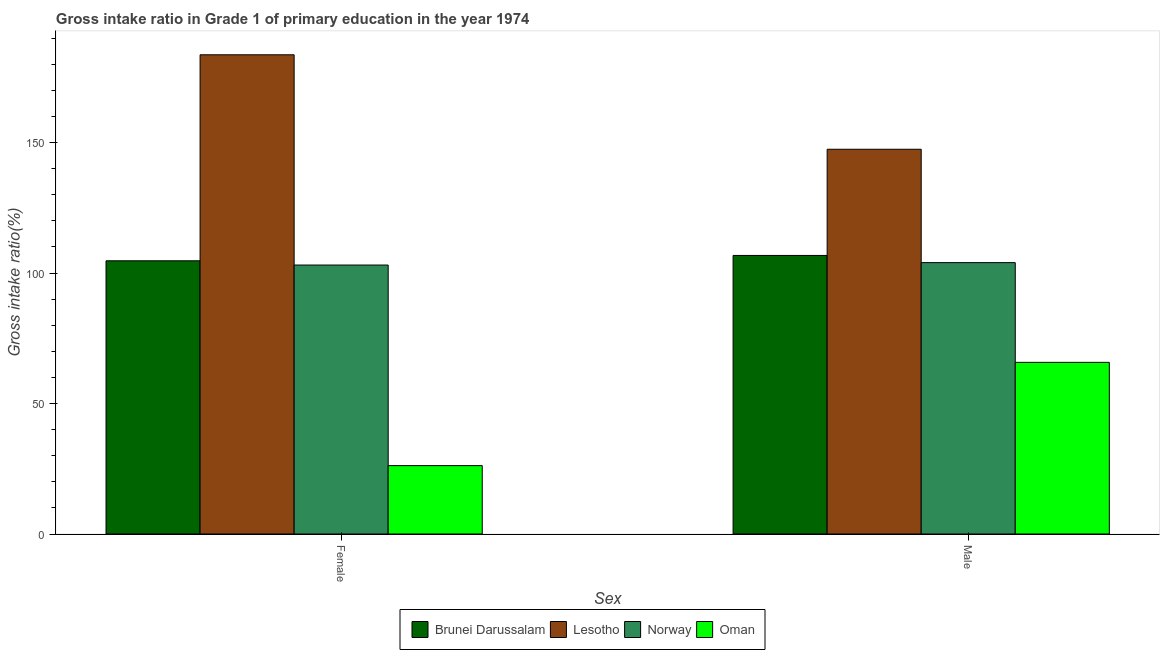How many different coloured bars are there?
Your response must be concise. 4. How many groups of bars are there?
Provide a short and direct response. 2. What is the label of the 1st group of bars from the left?
Ensure brevity in your answer.  Female. What is the gross intake ratio(male) in Lesotho?
Your response must be concise. 147.44. Across all countries, what is the maximum gross intake ratio(female)?
Offer a terse response. 183.65. Across all countries, what is the minimum gross intake ratio(male)?
Your answer should be compact. 65.78. In which country was the gross intake ratio(female) maximum?
Offer a very short reply. Lesotho. In which country was the gross intake ratio(female) minimum?
Your answer should be compact. Oman. What is the total gross intake ratio(female) in the graph?
Offer a terse response. 417.62. What is the difference between the gross intake ratio(male) in Oman and that in Lesotho?
Offer a terse response. -81.66. What is the difference between the gross intake ratio(male) in Norway and the gross intake ratio(female) in Oman?
Your answer should be very brief. 77.79. What is the average gross intake ratio(female) per country?
Your response must be concise. 104.4. What is the difference between the gross intake ratio(male) and gross intake ratio(female) in Lesotho?
Provide a short and direct response. -36.2. In how many countries, is the gross intake ratio(female) greater than 50 %?
Your response must be concise. 3. What is the ratio of the gross intake ratio(female) in Brunei Darussalam to that in Lesotho?
Provide a succinct answer. 0.57. Is the gross intake ratio(female) in Norway less than that in Oman?
Offer a terse response. No. What does the 2nd bar from the left in Male represents?
Offer a terse response. Lesotho. What does the 1st bar from the right in Male represents?
Offer a very short reply. Oman. What is the difference between two consecutive major ticks on the Y-axis?
Provide a succinct answer. 50. Does the graph contain grids?
Provide a short and direct response. No. How many legend labels are there?
Keep it short and to the point. 4. How are the legend labels stacked?
Provide a short and direct response. Horizontal. What is the title of the graph?
Make the answer very short. Gross intake ratio in Grade 1 of primary education in the year 1974. What is the label or title of the X-axis?
Offer a very short reply. Sex. What is the label or title of the Y-axis?
Your response must be concise. Gross intake ratio(%). What is the Gross intake ratio(%) in Brunei Darussalam in Female?
Give a very brief answer. 104.7. What is the Gross intake ratio(%) in Lesotho in Female?
Make the answer very short. 183.65. What is the Gross intake ratio(%) in Norway in Female?
Make the answer very short. 103.07. What is the Gross intake ratio(%) of Oman in Female?
Your answer should be compact. 26.2. What is the Gross intake ratio(%) in Brunei Darussalam in Male?
Your answer should be compact. 106.75. What is the Gross intake ratio(%) of Lesotho in Male?
Your answer should be compact. 147.44. What is the Gross intake ratio(%) of Norway in Male?
Offer a terse response. 104. What is the Gross intake ratio(%) of Oman in Male?
Give a very brief answer. 65.78. Across all Sex, what is the maximum Gross intake ratio(%) in Brunei Darussalam?
Make the answer very short. 106.75. Across all Sex, what is the maximum Gross intake ratio(%) in Lesotho?
Offer a terse response. 183.65. Across all Sex, what is the maximum Gross intake ratio(%) of Norway?
Provide a short and direct response. 104. Across all Sex, what is the maximum Gross intake ratio(%) of Oman?
Ensure brevity in your answer.  65.78. Across all Sex, what is the minimum Gross intake ratio(%) in Brunei Darussalam?
Your response must be concise. 104.7. Across all Sex, what is the minimum Gross intake ratio(%) of Lesotho?
Provide a succinct answer. 147.44. Across all Sex, what is the minimum Gross intake ratio(%) in Norway?
Offer a very short reply. 103.07. Across all Sex, what is the minimum Gross intake ratio(%) of Oman?
Provide a succinct answer. 26.2. What is the total Gross intake ratio(%) of Brunei Darussalam in the graph?
Ensure brevity in your answer.  211.45. What is the total Gross intake ratio(%) of Lesotho in the graph?
Your response must be concise. 331.09. What is the total Gross intake ratio(%) in Norway in the graph?
Your answer should be compact. 207.07. What is the total Gross intake ratio(%) in Oman in the graph?
Your answer should be very brief. 91.99. What is the difference between the Gross intake ratio(%) in Brunei Darussalam in Female and that in Male?
Give a very brief answer. -2.05. What is the difference between the Gross intake ratio(%) in Lesotho in Female and that in Male?
Your answer should be very brief. 36.2. What is the difference between the Gross intake ratio(%) in Norway in Female and that in Male?
Provide a succinct answer. -0.92. What is the difference between the Gross intake ratio(%) in Oman in Female and that in Male?
Offer a terse response. -39.58. What is the difference between the Gross intake ratio(%) of Brunei Darussalam in Female and the Gross intake ratio(%) of Lesotho in Male?
Your response must be concise. -42.75. What is the difference between the Gross intake ratio(%) in Brunei Darussalam in Female and the Gross intake ratio(%) in Norway in Male?
Your response must be concise. 0.7. What is the difference between the Gross intake ratio(%) of Brunei Darussalam in Female and the Gross intake ratio(%) of Oman in Male?
Ensure brevity in your answer.  38.92. What is the difference between the Gross intake ratio(%) in Lesotho in Female and the Gross intake ratio(%) in Norway in Male?
Your response must be concise. 79.65. What is the difference between the Gross intake ratio(%) in Lesotho in Female and the Gross intake ratio(%) in Oman in Male?
Your response must be concise. 117.86. What is the difference between the Gross intake ratio(%) in Norway in Female and the Gross intake ratio(%) in Oman in Male?
Ensure brevity in your answer.  37.29. What is the average Gross intake ratio(%) in Brunei Darussalam per Sex?
Give a very brief answer. 105.72. What is the average Gross intake ratio(%) of Lesotho per Sex?
Your response must be concise. 165.55. What is the average Gross intake ratio(%) of Norway per Sex?
Your response must be concise. 103.53. What is the average Gross intake ratio(%) of Oman per Sex?
Ensure brevity in your answer.  45.99. What is the difference between the Gross intake ratio(%) in Brunei Darussalam and Gross intake ratio(%) in Lesotho in Female?
Offer a terse response. -78.95. What is the difference between the Gross intake ratio(%) in Brunei Darussalam and Gross intake ratio(%) in Norway in Female?
Offer a very short reply. 1.63. What is the difference between the Gross intake ratio(%) of Brunei Darussalam and Gross intake ratio(%) of Oman in Female?
Make the answer very short. 78.49. What is the difference between the Gross intake ratio(%) in Lesotho and Gross intake ratio(%) in Norway in Female?
Your answer should be very brief. 80.57. What is the difference between the Gross intake ratio(%) of Lesotho and Gross intake ratio(%) of Oman in Female?
Make the answer very short. 157.44. What is the difference between the Gross intake ratio(%) of Norway and Gross intake ratio(%) of Oman in Female?
Keep it short and to the point. 76.87. What is the difference between the Gross intake ratio(%) of Brunei Darussalam and Gross intake ratio(%) of Lesotho in Male?
Your answer should be compact. -40.69. What is the difference between the Gross intake ratio(%) in Brunei Darussalam and Gross intake ratio(%) in Norway in Male?
Give a very brief answer. 2.76. What is the difference between the Gross intake ratio(%) of Brunei Darussalam and Gross intake ratio(%) of Oman in Male?
Offer a very short reply. 40.97. What is the difference between the Gross intake ratio(%) in Lesotho and Gross intake ratio(%) in Norway in Male?
Ensure brevity in your answer.  43.45. What is the difference between the Gross intake ratio(%) in Lesotho and Gross intake ratio(%) in Oman in Male?
Provide a short and direct response. 81.66. What is the difference between the Gross intake ratio(%) of Norway and Gross intake ratio(%) of Oman in Male?
Provide a succinct answer. 38.21. What is the ratio of the Gross intake ratio(%) in Brunei Darussalam in Female to that in Male?
Offer a terse response. 0.98. What is the ratio of the Gross intake ratio(%) in Lesotho in Female to that in Male?
Keep it short and to the point. 1.25. What is the ratio of the Gross intake ratio(%) in Oman in Female to that in Male?
Your answer should be very brief. 0.4. What is the difference between the highest and the second highest Gross intake ratio(%) in Brunei Darussalam?
Keep it short and to the point. 2.05. What is the difference between the highest and the second highest Gross intake ratio(%) of Lesotho?
Your answer should be very brief. 36.2. What is the difference between the highest and the second highest Gross intake ratio(%) in Norway?
Offer a very short reply. 0.92. What is the difference between the highest and the second highest Gross intake ratio(%) of Oman?
Offer a very short reply. 39.58. What is the difference between the highest and the lowest Gross intake ratio(%) of Brunei Darussalam?
Ensure brevity in your answer.  2.05. What is the difference between the highest and the lowest Gross intake ratio(%) of Lesotho?
Offer a very short reply. 36.2. What is the difference between the highest and the lowest Gross intake ratio(%) of Norway?
Offer a terse response. 0.92. What is the difference between the highest and the lowest Gross intake ratio(%) of Oman?
Make the answer very short. 39.58. 